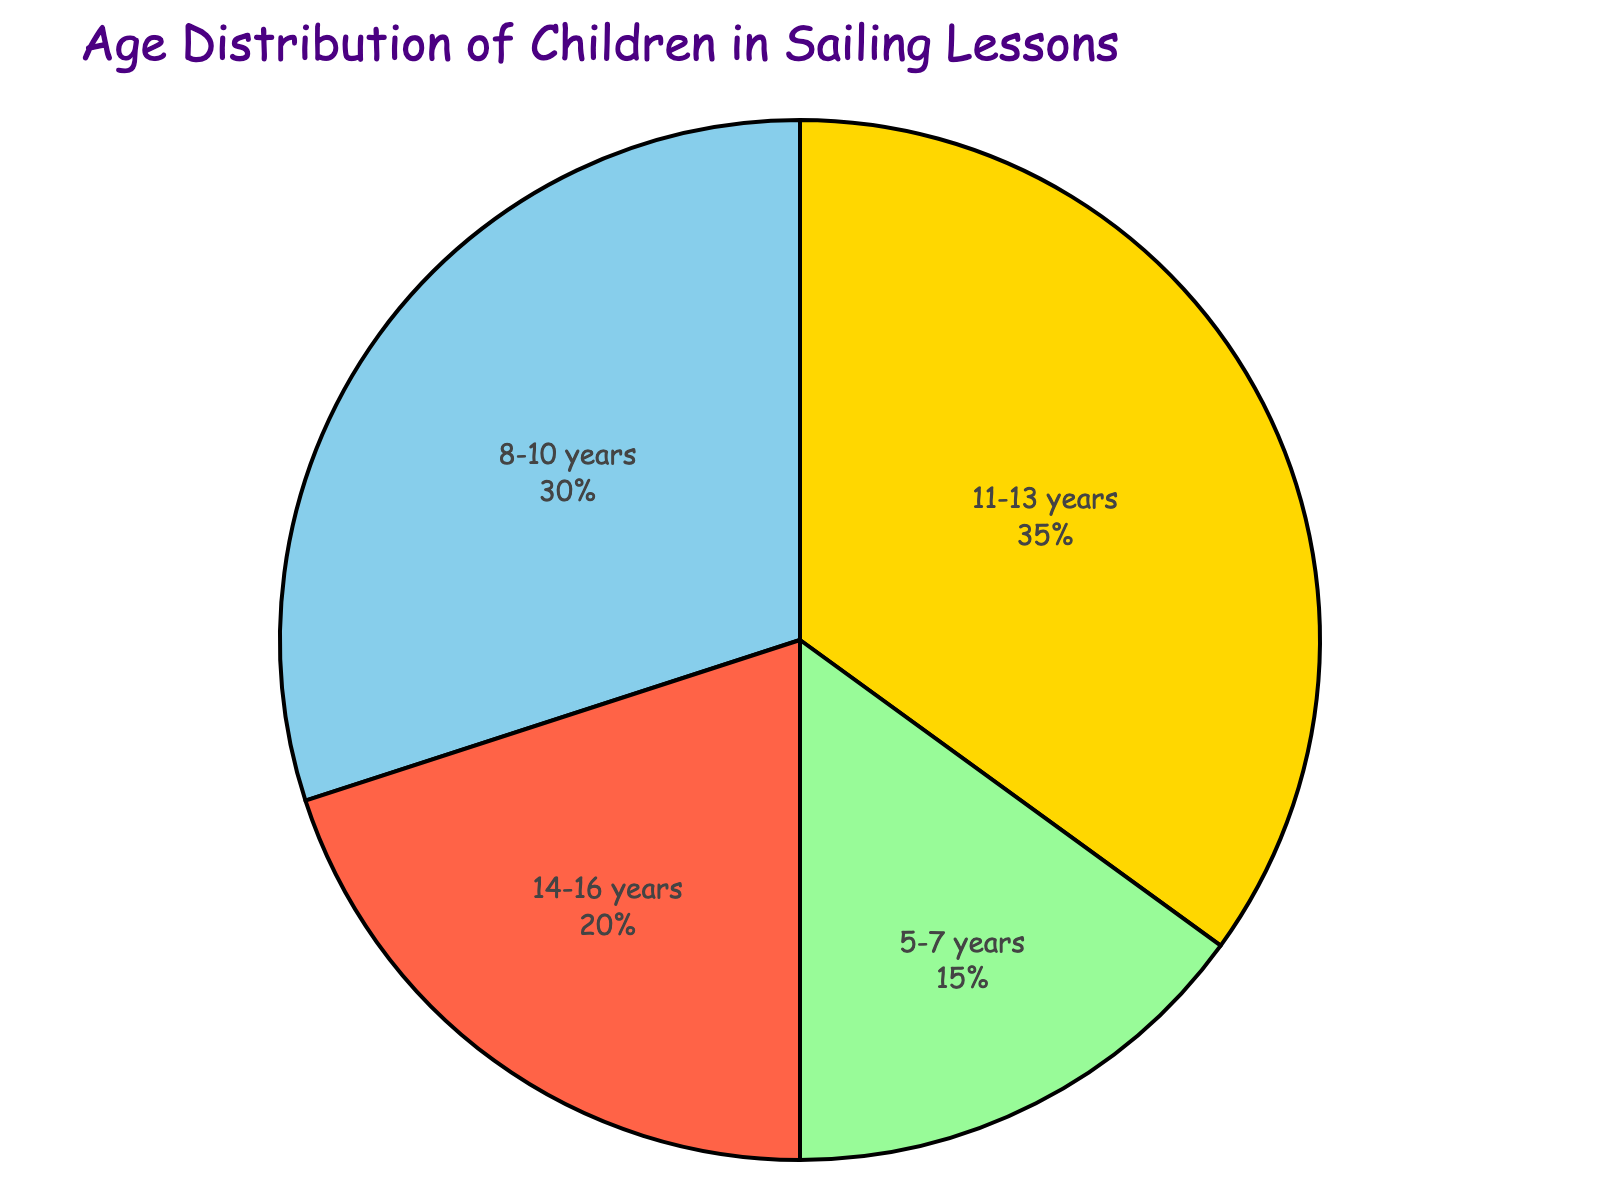What's the age group with the highest percentage of children? The section with the largest slice represents the age group with the highest percentage. The slice labeled "11-13 years" is the largest, indicating it's the age group with the highest percentage.
Answer: 11-13 years What's the combined percentage of children aged 8-10 years and 14-16 years? Add the percentages of the "8-10 years" and "14-16 years" slices: 30% for 8-10 years and 20% for 14-16 years. 30 + 20 = 50%.
Answer: 50% Which age group has the smallest percentage of children, and what is that percentage? The slice labeled "5-7 years" is the smallest. Its percentage is shown as 15%.
Answer: 5-7 years, 15% How much larger is the percentage for children aged 11-13 years compared to children aged 5-7 years? Subtract the percentage for 5-7 years from the percentage for 11-13 years: 35% - 15%. 35 - 15 = 20%.
Answer: 20% How does the percentage of children aged 8-10 years compare to those aged 11-13 years? Compare the percentages for 8-10 years and 11-13 years. The 8-10 years slice is 30%, while the 11-13 years slice is 35%. 35% is greater than 30%.
Answer: 11-13 years > 8-10 years What percentage of the children are older than 10 years? Add the percentages for the age groups older than 10 years: 11-13 years (35%) and 14-16 years (20%). 35 + 20 = 55%.
Answer: 55% Which age group is represented by a slice with a yellow color? The slice representing the "5-7 years" age group is colored yellow, as noted in the visual attributes.
Answer: 5-7 years What's the total percentage of children aged 5-7 years and 11-13 years combined? Add the percentages for the 5-7 years and 11-13 years age groups: 15% + 35%. 15 + 35 = 50%.
Answer: 50% If the age group with the lowest percentage increased by 5%, what would the new percentage be? Add 5% to the current percentage of the lowest age group (5-7 years): 15% + 5%. 15 + 5 = 20%.
Answer: 20% What's the average percentage of the age groups? Add up all the percentages and divide by the number of age groups: (15% + 30% + 35% + 20%) / 4. That totals to 100%, and 100 / 4 = 25%.
Answer: 25% 